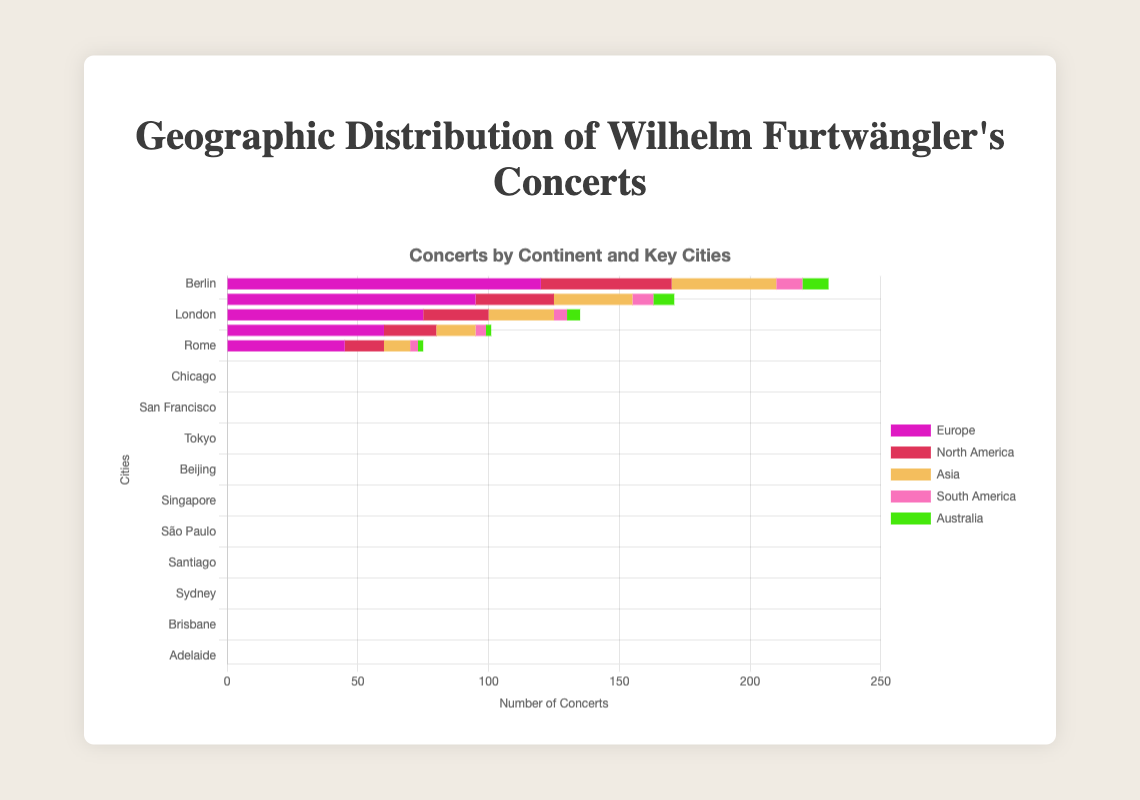Which continent has the highest number of concerts? Looking at the data, Europe has the highest number of concerts when summing up the values for Berlin, Vienna, London, Paris, and Rome (120 + 95 + 75 + 60 + 45 = 395).
Answer: Europe Which city in North America hosted the most concerts? In North America, the city with the highest number of concerts is New York, which hosted 50 concerts.
Answer: New York What is the total number of concerts held in Asia? Sum the number of concerts for Tokyo, Shanghai, Beijing, Seoul, and Singapore (40 + 30 + 25 + 15 + 10 = 120).
Answer: 120 How does the number of concerts in London compare to New York? London had 75 concerts, while New York had 50 concerts. Thus, London had more concerts compared to New York by 25 concerts.
Answer: London had more Which continent had the least number of concerts and how many? By comparing the total number of concerts (South America: 30, Australia: 27, Asia: 120, North America: 140, Europe: 395), South America had the least with 30 concerts.
Answer: South America What is the combined number of concerts held in Berlin and Vienna? Sum the concerts held in Berlin and Vienna (120 + 95 = 215).
Answer: 215 Which city had the lowest number of concerts, and how many was it? Lima, in South America, had the lowest number of concerts, with only 3 concerts.
Answer: Lima, 3 How many more concerts were held in South America compared to Australia? Subtract the total number of concerts in Australia from South America (30 - 27 = 3).
Answer: 3 more in South America What is the average number of concerts held across all the key cities in Australia? Sum the concerts in Sydney, Melbourne, Brisbane, Perth, and Adelaide (10 + 8 + 5 + 2 + 2 = 27) and divide by the number of cities (27 / 5 = 5.4).
Answer: 5.4 Comparing Paris (60 concerts) and Tokyo (40 concerts), which city had more concerts and by how many? Paris had 60 concerts and Tokyo had 40 concerts. Paris had 20 more concerts than Tokyo (60 - 40 = 20).
Answer: Paris, 20 more 